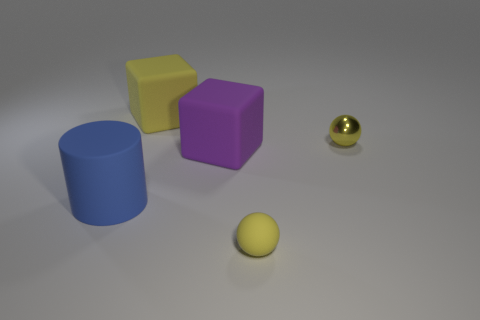How many large yellow rubber things are there?
Ensure brevity in your answer.  1. Does the purple block have the same material as the tiny yellow object in front of the tiny yellow shiny object?
Your answer should be very brief. Yes. How many gray objects are either rubber objects or blocks?
Provide a succinct answer. 0. What is the size of the purple block that is the same material as the large yellow cube?
Make the answer very short. Large. How many big yellow objects are the same shape as the purple object?
Your answer should be compact. 1. Are there more matte cylinders that are right of the small rubber sphere than spheres that are in front of the blue thing?
Provide a succinct answer. No. Is the color of the tiny rubber ball the same as the small ball behind the large purple block?
Offer a very short reply. Yes. There is a cylinder that is the same size as the purple cube; what is it made of?
Offer a very short reply. Rubber. How many objects are cyan matte spheres or matte things that are behind the yellow matte ball?
Your answer should be very brief. 3. There is a yellow shiny sphere; is its size the same as the matte cylinder on the left side of the small rubber ball?
Provide a succinct answer. No. 